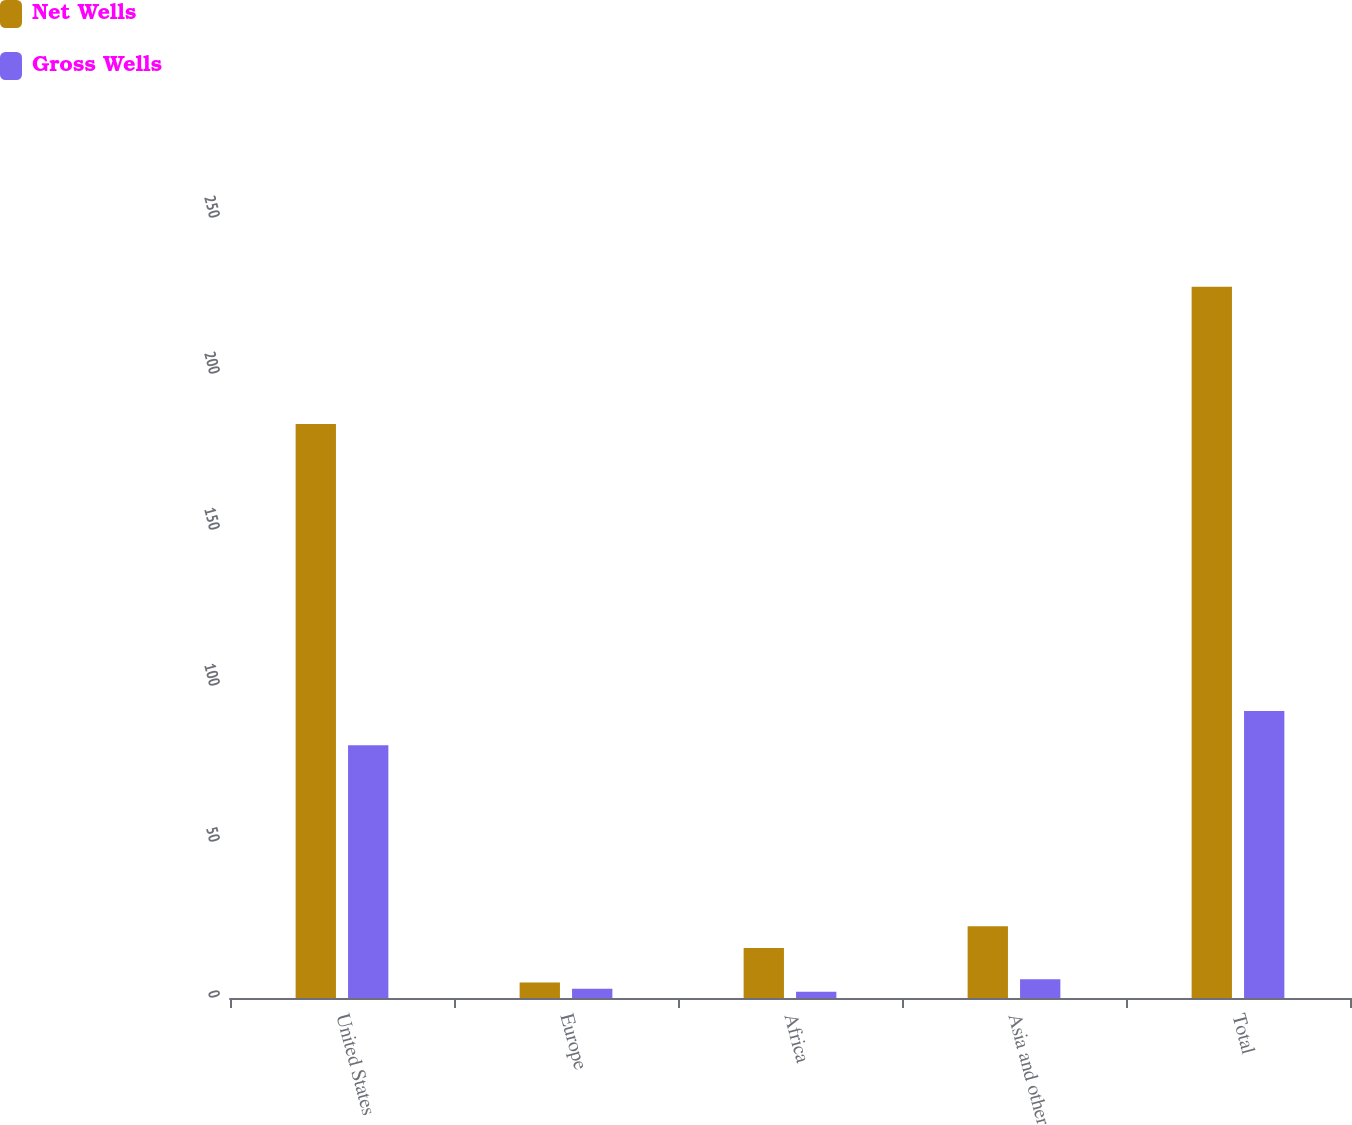<chart> <loc_0><loc_0><loc_500><loc_500><stacked_bar_chart><ecel><fcel>United States<fcel>Europe<fcel>Africa<fcel>Asia and other<fcel>Total<nl><fcel>Net Wells<fcel>184<fcel>5<fcel>16<fcel>23<fcel>228<nl><fcel>Gross Wells<fcel>81<fcel>3<fcel>2<fcel>6<fcel>92<nl></chart> 